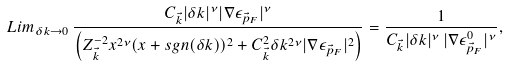<formula> <loc_0><loc_0><loc_500><loc_500>L i m _ { \delta k \to 0 } \, \frac { C _ { \vec { k } } | \delta k | ^ { \nu } | \nabla \epsilon _ { \vec { p } _ { F } } | ^ { \nu } } { \left ( Z _ { \vec { k } } ^ { - 2 } x ^ { 2 \nu } ( x + s g n ( \delta k ) ) ^ { 2 } + C _ { \vec { k } } ^ { 2 } \delta k ^ { 2 \nu } | \nabla \epsilon _ { \vec { p } _ { F } } | ^ { 2 } \right ) } = \frac { 1 } { C _ { \vec { k } } | \delta k | ^ { \nu } \, | \nabla \epsilon ^ { 0 } _ { \vec { p } _ { F } } | ^ { \nu } } ,</formula> 